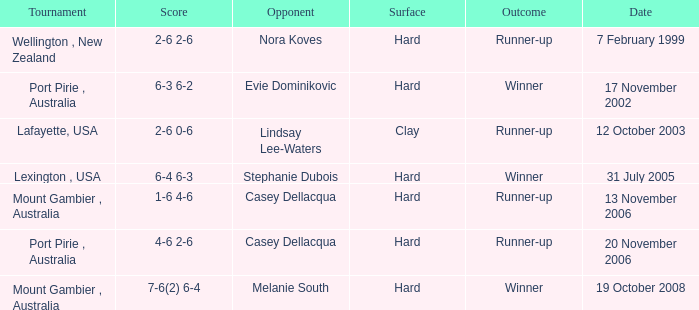When is an Opponent of evie dominikovic? 17 November 2002. 